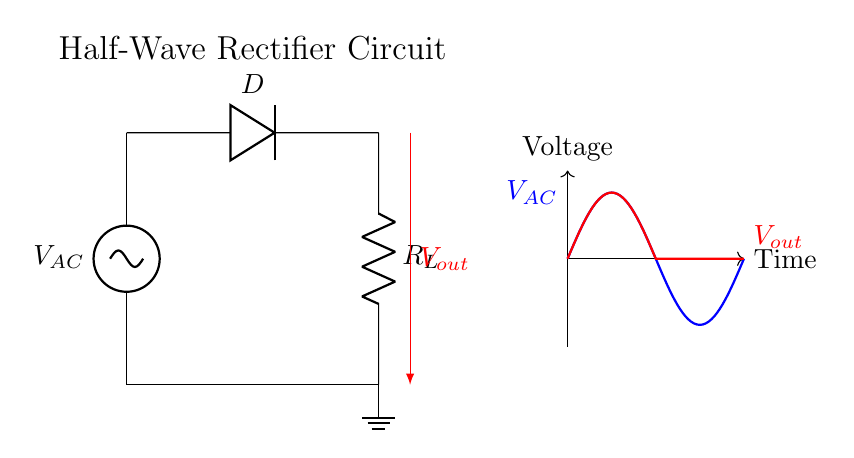What is the type of rectifier shown in the circuit? The circuit is a half-wave rectifier, which converts alternating current (AC) to pulsating direct current (DC) using a single diode.
Answer: Half-wave What component is responsible for allowing current to flow in one direction only? The diode in the circuit is the component that allows current to flow in one direction, preventing it from flowing back.
Answer: Diode What does the load resistor represent in the circuit? The load resistor represents the device or component that consumes the electrical energy output from the rectifier, converting it to useful work such as lighting or charging a battery.
Answer: Load resistor During which half-cycle of the AC waveform does the output voltage occur? The output voltage occurs during the positive half-cycle of the AC waveform, as the diode only conducts when the input voltage is positive.
Answer: Positive half-cycle What is the shape of the output voltage waveform? The output voltage waveform is a pulsating waveform, resembling half of the AC waveform, as the negative half-cycle is blocked by the diode and does not appear in the output.
Answer: Pulsating How many diodes are used in this half-wave rectifier circuit? There is only one diode used in this circuit, which is sufficient for converting the AC input to pulsating DC output.
Answer: One diode 